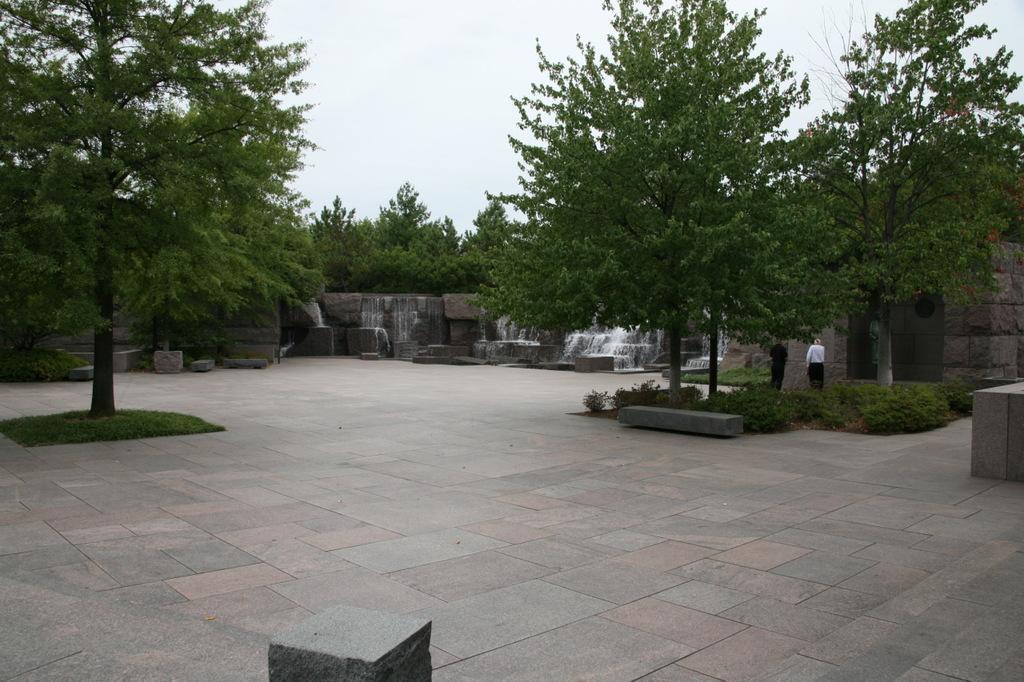Describe this image in one or two sentences. In this image there are two trees on the floor. In the background there is a waterfall. At the top there is sky. On the right side there are two persons standing on the floor. On the floor there are rough tiles. In the background there are stones on the right side. 